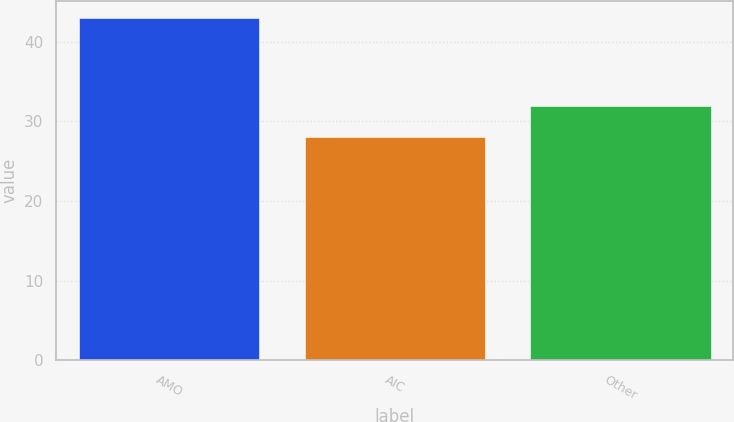Convert chart. <chart><loc_0><loc_0><loc_500><loc_500><bar_chart><fcel>AMO<fcel>AIC<fcel>Other<nl><fcel>43<fcel>28<fcel>32<nl></chart> 